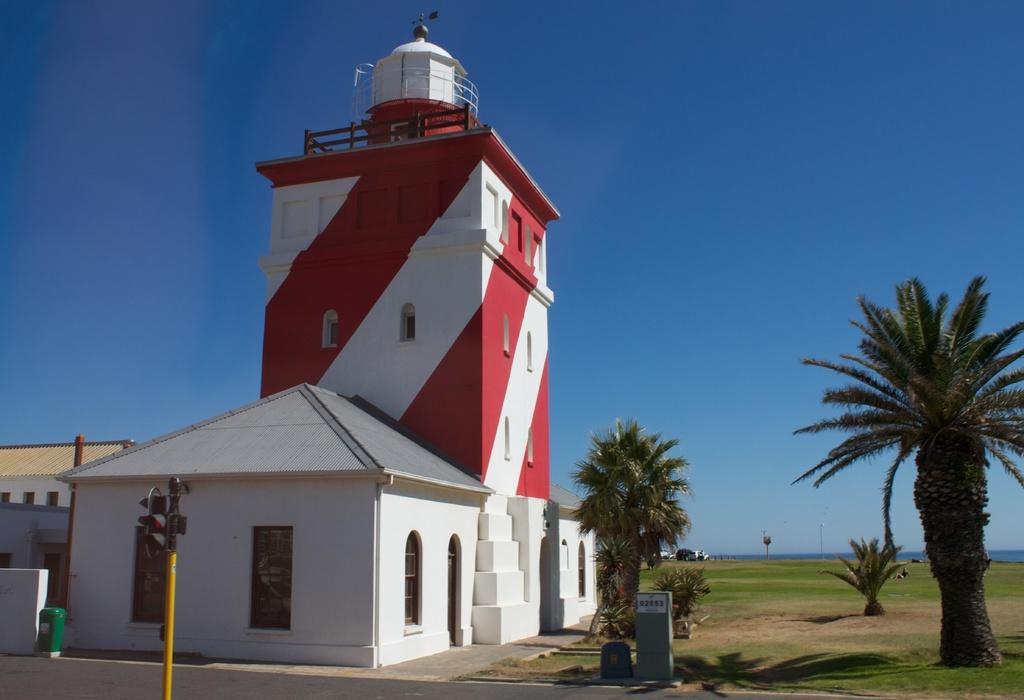What is the main structure in the center of the image? There is a building in the center of the image. What can be seen near the building? There is a traffic signal in the image. What type of vegetation is present in the image? There are trees and grass in the image. What is visible at the top of the image? The sky is visible at the top of the image. Where is the lead mine located in the image? There is no lead mine present in the image. What type of plantation can be seen in the image? There is no plantation present in the image. 